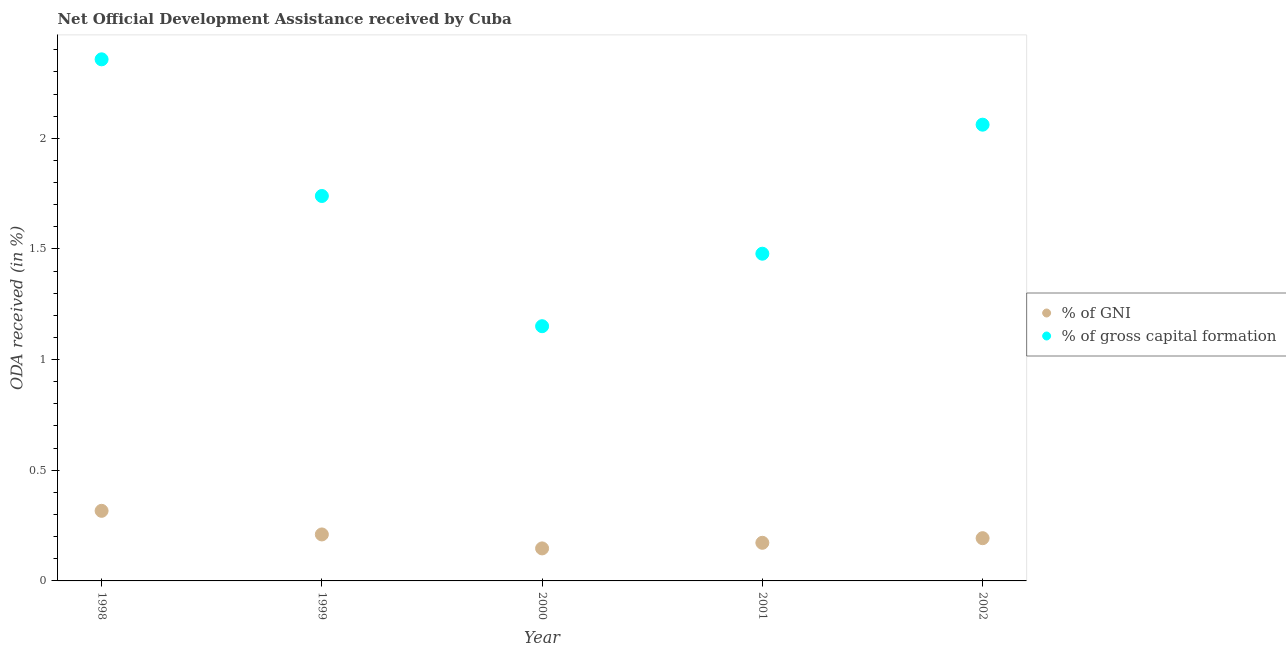Is the number of dotlines equal to the number of legend labels?
Your answer should be compact. Yes. What is the oda received as percentage of gni in 2002?
Your answer should be compact. 0.19. Across all years, what is the maximum oda received as percentage of gni?
Provide a succinct answer. 0.32. Across all years, what is the minimum oda received as percentage of gross capital formation?
Give a very brief answer. 1.15. In which year was the oda received as percentage of gni maximum?
Your answer should be compact. 1998. What is the total oda received as percentage of gni in the graph?
Make the answer very short. 1.04. What is the difference between the oda received as percentage of gross capital formation in 1998 and that in 2000?
Offer a terse response. 1.21. What is the difference between the oda received as percentage of gross capital formation in 1998 and the oda received as percentage of gni in 2000?
Offer a very short reply. 2.21. What is the average oda received as percentage of gni per year?
Your response must be concise. 0.21. In the year 2002, what is the difference between the oda received as percentage of gross capital formation and oda received as percentage of gni?
Provide a short and direct response. 1.87. In how many years, is the oda received as percentage of gross capital formation greater than 0.2 %?
Your answer should be very brief. 5. What is the ratio of the oda received as percentage of gni in 2000 to that in 2001?
Give a very brief answer. 0.85. Is the oda received as percentage of gross capital formation in 1998 less than that in 2002?
Your answer should be compact. No. Is the difference between the oda received as percentage of gross capital formation in 2001 and 2002 greater than the difference between the oda received as percentage of gni in 2001 and 2002?
Provide a succinct answer. No. What is the difference between the highest and the second highest oda received as percentage of gross capital formation?
Provide a short and direct response. 0.3. What is the difference between the highest and the lowest oda received as percentage of gni?
Provide a succinct answer. 0.17. Is the sum of the oda received as percentage of gni in 1998 and 1999 greater than the maximum oda received as percentage of gross capital formation across all years?
Your response must be concise. No. Does the oda received as percentage of gni monotonically increase over the years?
Provide a succinct answer. No. Is the oda received as percentage of gross capital formation strictly greater than the oda received as percentage of gni over the years?
Your answer should be compact. Yes. Is the oda received as percentage of gni strictly less than the oda received as percentage of gross capital formation over the years?
Make the answer very short. Yes. How many years are there in the graph?
Make the answer very short. 5. What is the difference between two consecutive major ticks on the Y-axis?
Make the answer very short. 0.5. Where does the legend appear in the graph?
Your answer should be very brief. Center right. What is the title of the graph?
Provide a succinct answer. Net Official Development Assistance received by Cuba. Does "Male population" appear as one of the legend labels in the graph?
Give a very brief answer. No. What is the label or title of the X-axis?
Offer a terse response. Year. What is the label or title of the Y-axis?
Offer a very short reply. ODA received (in %). What is the ODA received (in %) of % of GNI in 1998?
Provide a succinct answer. 0.32. What is the ODA received (in %) of % of gross capital formation in 1998?
Your answer should be very brief. 2.36. What is the ODA received (in %) of % of GNI in 1999?
Provide a short and direct response. 0.21. What is the ODA received (in %) of % of gross capital formation in 1999?
Offer a terse response. 1.74. What is the ODA received (in %) of % of GNI in 2000?
Provide a succinct answer. 0.15. What is the ODA received (in %) in % of gross capital formation in 2000?
Give a very brief answer. 1.15. What is the ODA received (in %) of % of GNI in 2001?
Ensure brevity in your answer.  0.17. What is the ODA received (in %) of % of gross capital formation in 2001?
Make the answer very short. 1.48. What is the ODA received (in %) of % of GNI in 2002?
Provide a succinct answer. 0.19. What is the ODA received (in %) of % of gross capital formation in 2002?
Give a very brief answer. 2.06. Across all years, what is the maximum ODA received (in %) in % of GNI?
Offer a terse response. 0.32. Across all years, what is the maximum ODA received (in %) of % of gross capital formation?
Keep it short and to the point. 2.36. Across all years, what is the minimum ODA received (in %) of % of GNI?
Your answer should be compact. 0.15. Across all years, what is the minimum ODA received (in %) in % of gross capital formation?
Provide a short and direct response. 1.15. What is the total ODA received (in %) of % of GNI in the graph?
Make the answer very short. 1.04. What is the total ODA received (in %) of % of gross capital formation in the graph?
Provide a succinct answer. 8.79. What is the difference between the ODA received (in %) of % of GNI in 1998 and that in 1999?
Make the answer very short. 0.11. What is the difference between the ODA received (in %) in % of gross capital formation in 1998 and that in 1999?
Make the answer very short. 0.62. What is the difference between the ODA received (in %) in % of GNI in 1998 and that in 2000?
Make the answer very short. 0.17. What is the difference between the ODA received (in %) in % of gross capital formation in 1998 and that in 2000?
Make the answer very short. 1.21. What is the difference between the ODA received (in %) in % of GNI in 1998 and that in 2001?
Ensure brevity in your answer.  0.14. What is the difference between the ODA received (in %) in % of gross capital formation in 1998 and that in 2001?
Your answer should be compact. 0.88. What is the difference between the ODA received (in %) in % of GNI in 1998 and that in 2002?
Ensure brevity in your answer.  0.12. What is the difference between the ODA received (in %) of % of gross capital formation in 1998 and that in 2002?
Provide a succinct answer. 0.3. What is the difference between the ODA received (in %) in % of GNI in 1999 and that in 2000?
Your answer should be compact. 0.06. What is the difference between the ODA received (in %) in % of gross capital formation in 1999 and that in 2000?
Your answer should be very brief. 0.59. What is the difference between the ODA received (in %) in % of GNI in 1999 and that in 2001?
Your answer should be very brief. 0.04. What is the difference between the ODA received (in %) of % of gross capital formation in 1999 and that in 2001?
Offer a very short reply. 0.26. What is the difference between the ODA received (in %) in % of GNI in 1999 and that in 2002?
Keep it short and to the point. 0.02. What is the difference between the ODA received (in %) of % of gross capital formation in 1999 and that in 2002?
Provide a succinct answer. -0.32. What is the difference between the ODA received (in %) in % of GNI in 2000 and that in 2001?
Offer a terse response. -0.03. What is the difference between the ODA received (in %) in % of gross capital formation in 2000 and that in 2001?
Your answer should be very brief. -0.33. What is the difference between the ODA received (in %) of % of GNI in 2000 and that in 2002?
Make the answer very short. -0.05. What is the difference between the ODA received (in %) in % of gross capital formation in 2000 and that in 2002?
Give a very brief answer. -0.91. What is the difference between the ODA received (in %) of % of GNI in 2001 and that in 2002?
Give a very brief answer. -0.02. What is the difference between the ODA received (in %) of % of gross capital formation in 2001 and that in 2002?
Your answer should be compact. -0.58. What is the difference between the ODA received (in %) in % of GNI in 1998 and the ODA received (in %) in % of gross capital formation in 1999?
Your answer should be very brief. -1.42. What is the difference between the ODA received (in %) of % of GNI in 1998 and the ODA received (in %) of % of gross capital formation in 2000?
Offer a very short reply. -0.83. What is the difference between the ODA received (in %) of % of GNI in 1998 and the ODA received (in %) of % of gross capital formation in 2001?
Your answer should be compact. -1.16. What is the difference between the ODA received (in %) in % of GNI in 1998 and the ODA received (in %) in % of gross capital formation in 2002?
Keep it short and to the point. -1.74. What is the difference between the ODA received (in %) of % of GNI in 1999 and the ODA received (in %) of % of gross capital formation in 2000?
Your answer should be compact. -0.94. What is the difference between the ODA received (in %) in % of GNI in 1999 and the ODA received (in %) in % of gross capital formation in 2001?
Provide a succinct answer. -1.27. What is the difference between the ODA received (in %) in % of GNI in 1999 and the ODA received (in %) in % of gross capital formation in 2002?
Keep it short and to the point. -1.85. What is the difference between the ODA received (in %) of % of GNI in 2000 and the ODA received (in %) of % of gross capital formation in 2001?
Make the answer very short. -1.33. What is the difference between the ODA received (in %) of % of GNI in 2000 and the ODA received (in %) of % of gross capital formation in 2002?
Offer a very short reply. -1.91. What is the difference between the ODA received (in %) in % of GNI in 2001 and the ODA received (in %) in % of gross capital formation in 2002?
Offer a terse response. -1.89. What is the average ODA received (in %) of % of GNI per year?
Provide a succinct answer. 0.21. What is the average ODA received (in %) of % of gross capital formation per year?
Your answer should be compact. 1.76. In the year 1998, what is the difference between the ODA received (in %) in % of GNI and ODA received (in %) in % of gross capital formation?
Offer a very short reply. -2.04. In the year 1999, what is the difference between the ODA received (in %) in % of GNI and ODA received (in %) in % of gross capital formation?
Provide a succinct answer. -1.53. In the year 2000, what is the difference between the ODA received (in %) in % of GNI and ODA received (in %) in % of gross capital formation?
Provide a short and direct response. -1. In the year 2001, what is the difference between the ODA received (in %) of % of GNI and ODA received (in %) of % of gross capital formation?
Provide a short and direct response. -1.31. In the year 2002, what is the difference between the ODA received (in %) in % of GNI and ODA received (in %) in % of gross capital formation?
Give a very brief answer. -1.87. What is the ratio of the ODA received (in %) of % of GNI in 1998 to that in 1999?
Make the answer very short. 1.51. What is the ratio of the ODA received (in %) of % of gross capital formation in 1998 to that in 1999?
Provide a short and direct response. 1.35. What is the ratio of the ODA received (in %) of % of GNI in 1998 to that in 2000?
Give a very brief answer. 2.16. What is the ratio of the ODA received (in %) in % of gross capital formation in 1998 to that in 2000?
Make the answer very short. 2.05. What is the ratio of the ODA received (in %) of % of GNI in 1998 to that in 2001?
Your answer should be compact. 1.84. What is the ratio of the ODA received (in %) of % of gross capital formation in 1998 to that in 2001?
Your response must be concise. 1.59. What is the ratio of the ODA received (in %) in % of GNI in 1998 to that in 2002?
Offer a terse response. 1.64. What is the ratio of the ODA received (in %) in % of gross capital formation in 1998 to that in 2002?
Your answer should be compact. 1.14. What is the ratio of the ODA received (in %) of % of GNI in 1999 to that in 2000?
Offer a very short reply. 1.43. What is the ratio of the ODA received (in %) in % of gross capital formation in 1999 to that in 2000?
Your response must be concise. 1.51. What is the ratio of the ODA received (in %) of % of GNI in 1999 to that in 2001?
Keep it short and to the point. 1.22. What is the ratio of the ODA received (in %) in % of gross capital formation in 1999 to that in 2001?
Provide a short and direct response. 1.18. What is the ratio of the ODA received (in %) of % of GNI in 1999 to that in 2002?
Make the answer very short. 1.09. What is the ratio of the ODA received (in %) in % of gross capital formation in 1999 to that in 2002?
Keep it short and to the point. 0.84. What is the ratio of the ODA received (in %) of % of GNI in 2000 to that in 2001?
Make the answer very short. 0.85. What is the ratio of the ODA received (in %) of % of gross capital formation in 2000 to that in 2001?
Your response must be concise. 0.78. What is the ratio of the ODA received (in %) of % of GNI in 2000 to that in 2002?
Your response must be concise. 0.76. What is the ratio of the ODA received (in %) in % of gross capital formation in 2000 to that in 2002?
Make the answer very short. 0.56. What is the ratio of the ODA received (in %) of % of GNI in 2001 to that in 2002?
Make the answer very short. 0.89. What is the ratio of the ODA received (in %) in % of gross capital formation in 2001 to that in 2002?
Keep it short and to the point. 0.72. What is the difference between the highest and the second highest ODA received (in %) of % of GNI?
Your response must be concise. 0.11. What is the difference between the highest and the second highest ODA received (in %) of % of gross capital formation?
Your response must be concise. 0.3. What is the difference between the highest and the lowest ODA received (in %) in % of GNI?
Ensure brevity in your answer.  0.17. What is the difference between the highest and the lowest ODA received (in %) in % of gross capital formation?
Your answer should be very brief. 1.21. 